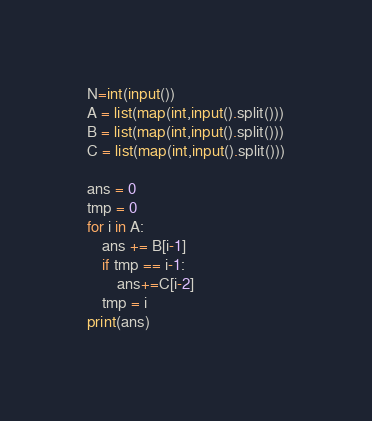<code> <loc_0><loc_0><loc_500><loc_500><_Python_>N=int(input())
A = list(map(int,input().split()))
B = list(map(int,input().split()))
C = list(map(int,input().split()))

ans = 0
tmp = 0
for i in A:
    ans += B[i-1]
    if tmp == i-1:
        ans+=C[i-2]
    tmp = i
print(ans)

</code> 